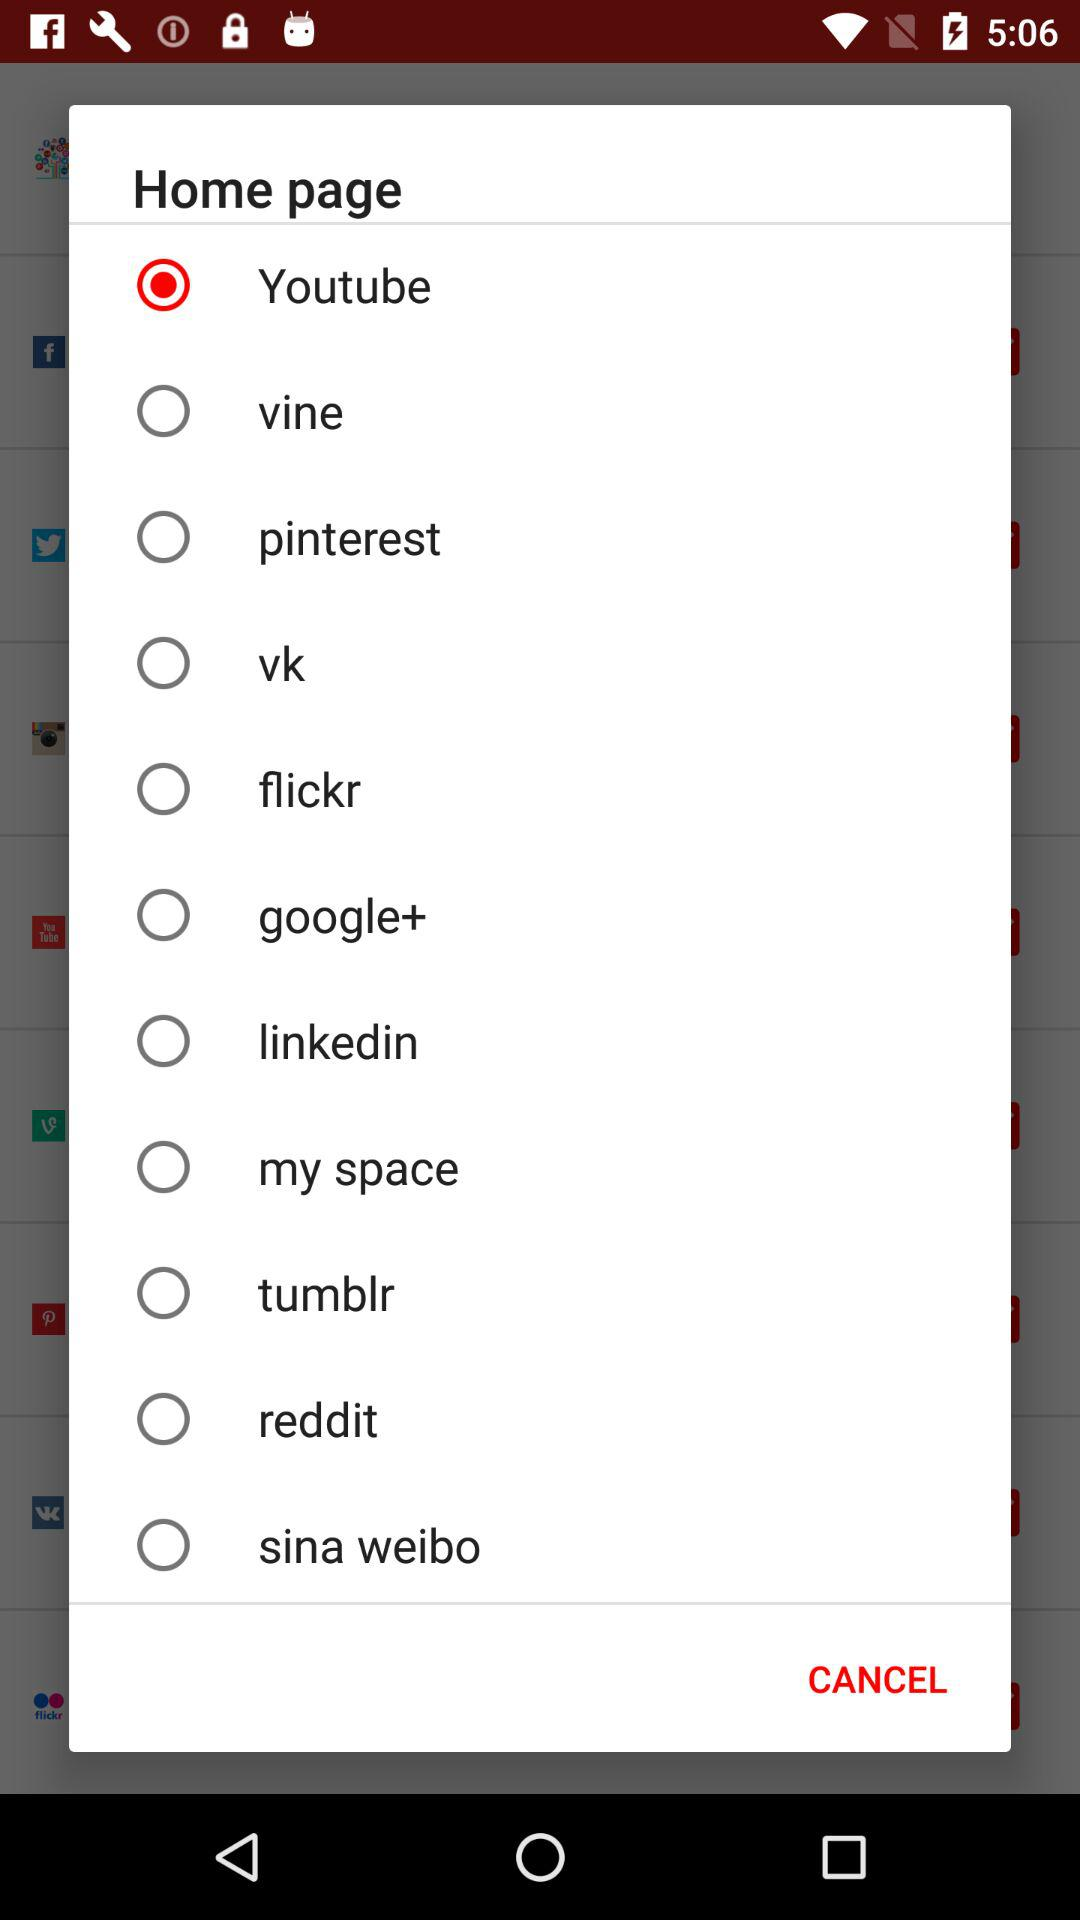Which option is selected? The selected option is "Youtube". 